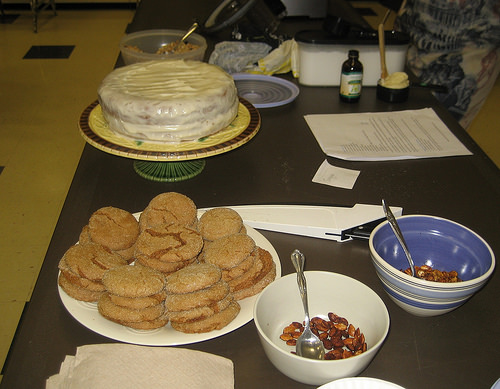<image>
Can you confirm if the cake is behind the cookies? Yes. From this viewpoint, the cake is positioned behind the cookies, with the cookies partially or fully occluding the cake. Is the cookie on the nuts? No. The cookie is not positioned on the nuts. They may be near each other, but the cookie is not supported by or resting on top of the nuts. 